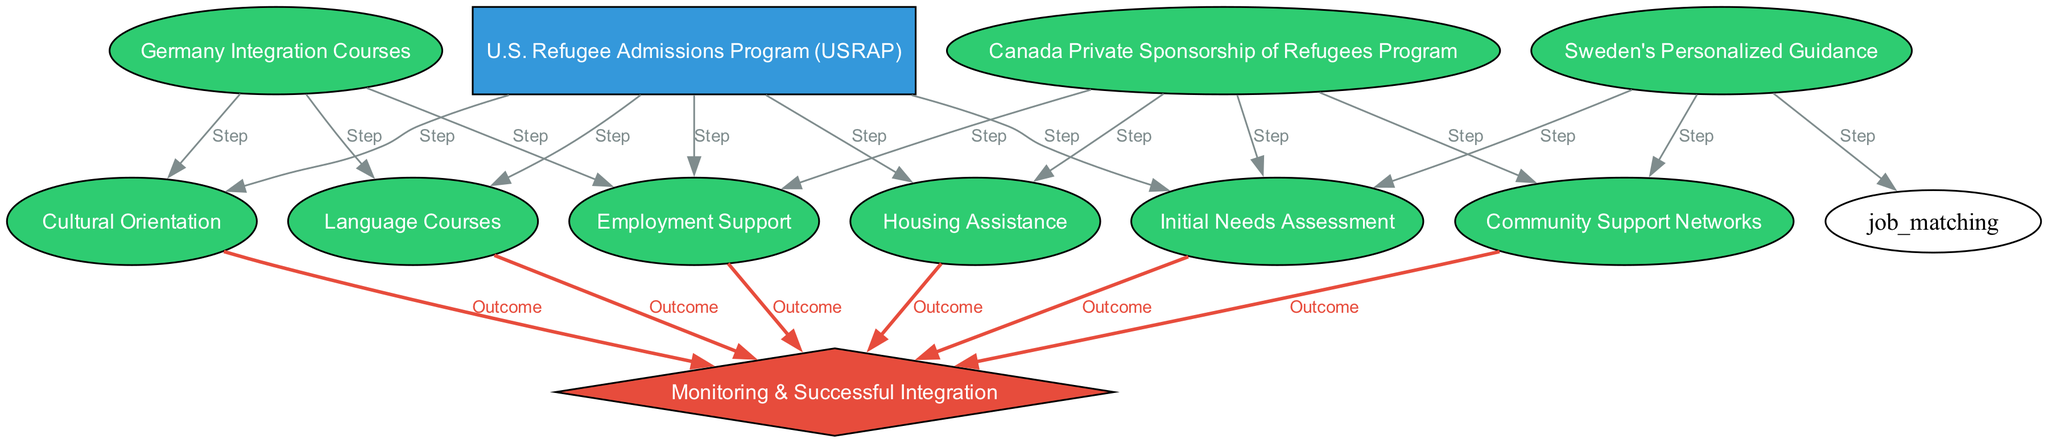What are the two programs listed in the diagram? The diagram includes the U.S. Refugee Admissions Program and Canada Private Sponsorship of Refugees Program as the two highlighted programs at the top.
Answer: U.S. Refugee Admissions Program, Canada Private Sponsorship of Refugees Program How many steps are associated with the U.S. Refugee Admissions Program? By reviewing the edges connected to the U.S. Refugee Admissions Program, there are five steps (Initial Needs Assessment, Cultural Orientation, Language Courses, Employment Support, Housing Assistance).
Answer: 5 Which program includes community support as a step? By examining the edges, community support is linked to both Canada Private Sponsorship of Refugees Program and Sweden's Personalized Guidance, indicating these programs include this aspect as a step.
Answer: Canada Private Sponsorship of Refugees Program, Sweden's Personalized Guidance What is the outcome node associated with steps from language courses? The language courses node has an edge connecting it to the Monitoring & Successful Integration node, indicating that it contributes to successful integration as an outcome.
Answer: Monitoring & Successful Integration How many programs include employment support? Looking at the diagram, both the U.S. Refugee Admissions Program, Canada Private Sponsorship of Refugees Program, and Germany Integration Courses include employment support as a step. Thus three programs feature this support.
Answer: 3 Which node serves as the final outcome in the integration diagram? The ultimate outcome that collects the result from various steps in the diagram is the Monitoring & Successful Integration node, which indicates overall success in integration.
Answer: Monitoring & Successful Integration What is the relationship between Germany Integration Courses and cultural orientation? The edge between Germany Integration Courses and Cultural Orientation shows that cultural orientation is established as a step in conjunction with the integration programs in Germany.
Answer: Step What does the arrow indicate between needs assessment and monitoring successful integration? The arrow indicates that the needs assessment step directly contributes to the outcome of monitoring successful integration, showing its importance in the overall process.
Answer: Outcome 